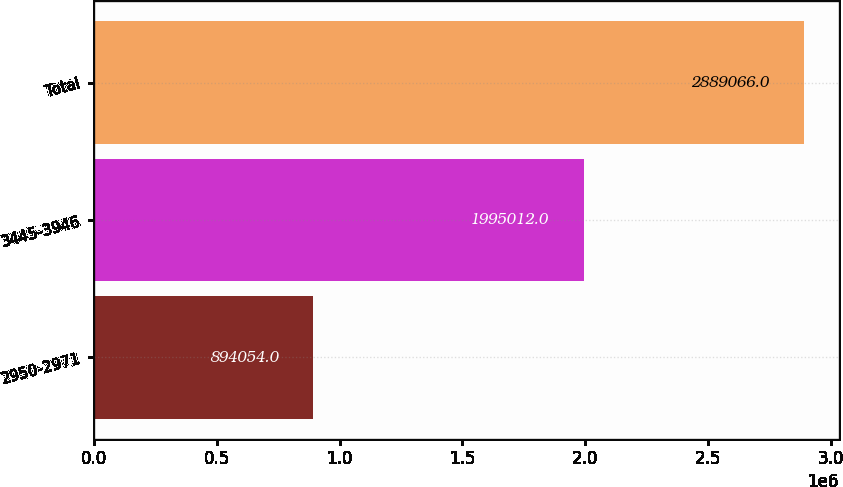<chart> <loc_0><loc_0><loc_500><loc_500><bar_chart><fcel>2950-2971<fcel>3445-3946<fcel>Total<nl><fcel>894054<fcel>1.99501e+06<fcel>2.88907e+06<nl></chart> 